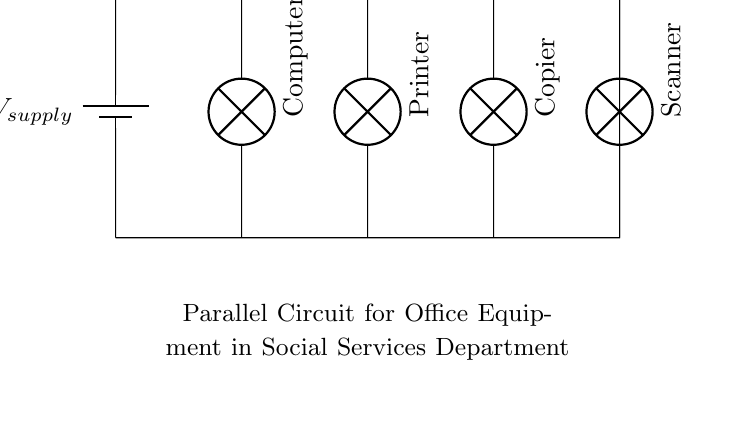What is the supply voltage for the circuit? The supply voltage is indicated at the battery symbol in the diagram. Since there is no numerical value provided, it is commonly represented as a variable, implying it can vary depending on the system.
Answer: Vsupply How many devices are connected in parallel in this circuit? The circuit shows four devices connected; specifically, they are a computer, printer, copier, and scanner. Since all are connected along the same supply voltage path, they are indeed in parallel.
Answer: Four What type of circuit is depicted? The circuit diagram represents a parallel circuit. All devices branch off from the same supply, indicating that they operate independently, which is characteristic of parallel circuits.
Answer: Parallel Can the voltage across each device in the circuit be different? In a parallel circuit, the voltage across each device remains the same as the supply voltage. Therefore, each device receives the same voltage regardless of its resistance or power consumption, leading to consistent voltage across all branches.
Answer: No What would happen if one device, like the printer, fails? In a parallel circuit, if one device fails (e.g., if the printer goes out), the other devices remain powered and operational since they are not dependent on a single path for current, common in series circuits.
Answer: Other devices still work Which device likely consumes the most power? To determine which device consumes the most power, we would need to consider their specifications. Typically, printers and copiers consume more power compared to computers and scanners based on average specifications. However, the exact device can only be determined if power ratings are given.
Answer: Copier 